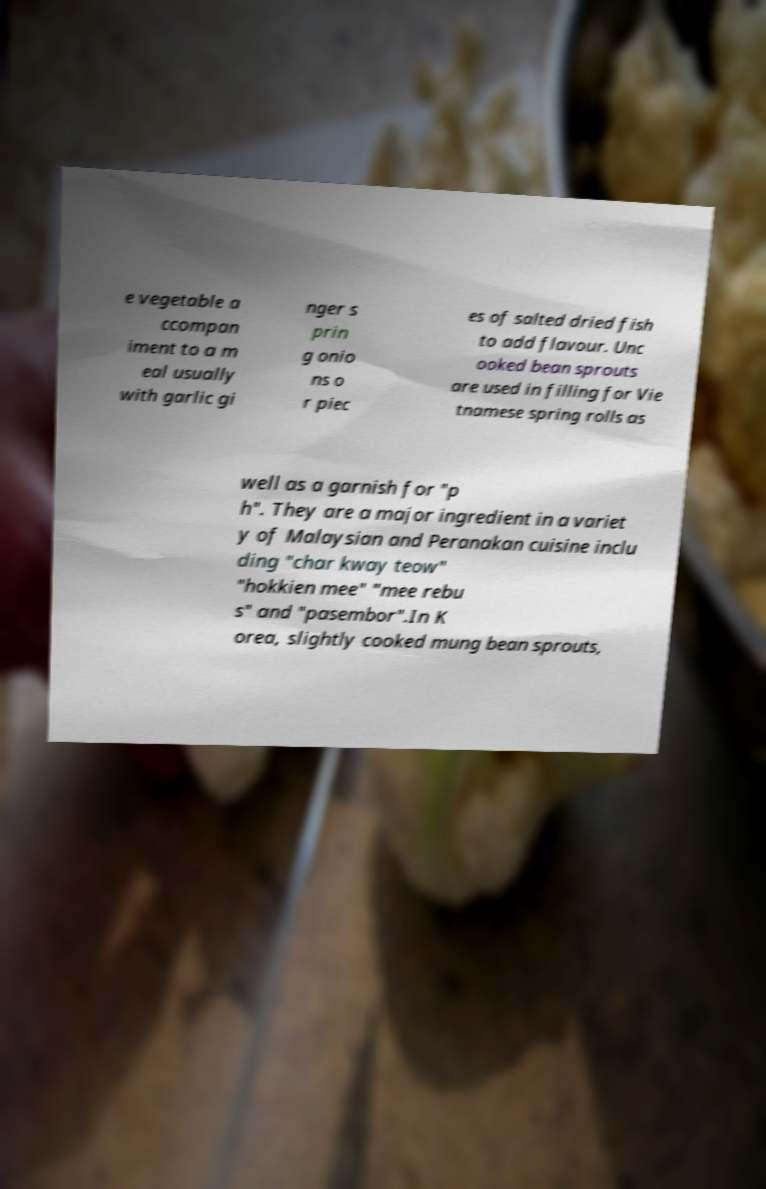Can you read and provide the text displayed in the image?This photo seems to have some interesting text. Can you extract and type it out for me? e vegetable a ccompan iment to a m eal usually with garlic gi nger s prin g onio ns o r piec es of salted dried fish to add flavour. Unc ooked bean sprouts are used in filling for Vie tnamese spring rolls as well as a garnish for "p h". They are a major ingredient in a variet y of Malaysian and Peranakan cuisine inclu ding "char kway teow" "hokkien mee" "mee rebu s" and "pasembor".In K orea, slightly cooked mung bean sprouts, 